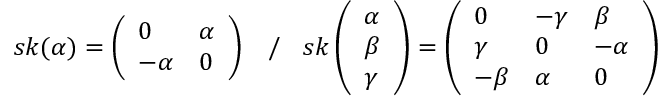<formula> <loc_0><loc_0><loc_500><loc_500>s k ( \alpha ) = \left ( \begin{array} { l l } { 0 } & { \alpha } \\ { - \alpha } & { 0 } \end{array} \right ) \, / \, s k \left ( \begin{array} { l } { \alpha } \\ { \beta } \\ { \gamma } \end{array} \right ) = \left ( \begin{array} { l l l } { 0 } & { - \gamma } & { \beta } \\ { \gamma } & { 0 } & { - \alpha } \\ { - \beta } & { \alpha } & { 0 } \end{array} \right )</formula> 